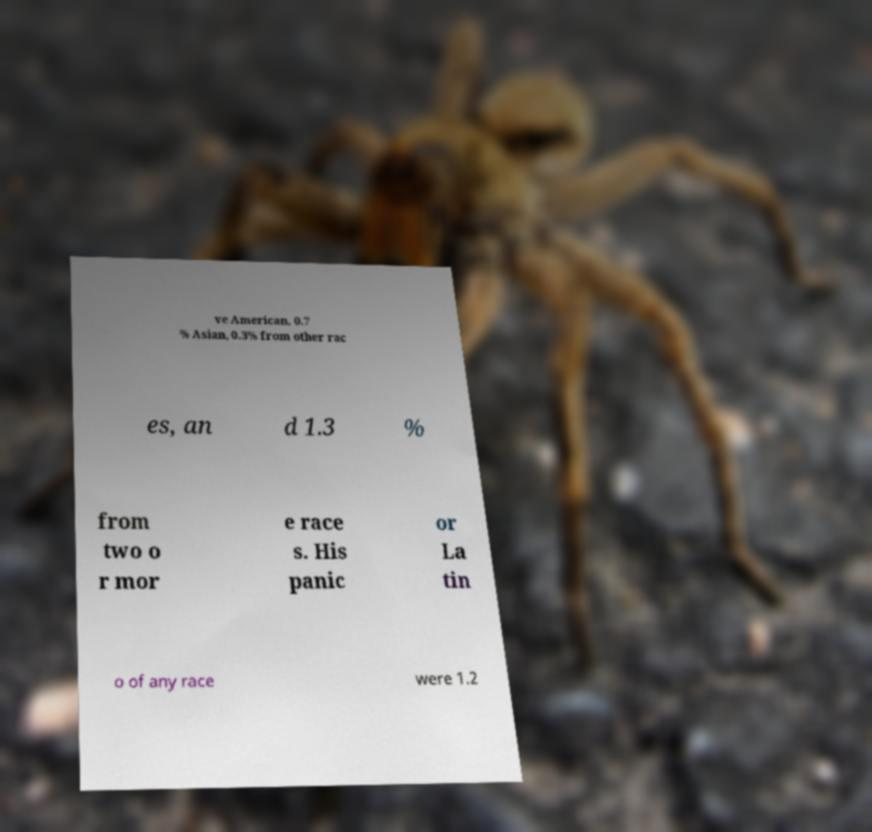I need the written content from this picture converted into text. Can you do that? ve American, 0.7 % Asian, 0.3% from other rac es, an d 1.3 % from two o r mor e race s. His panic or La tin o of any race were 1.2 